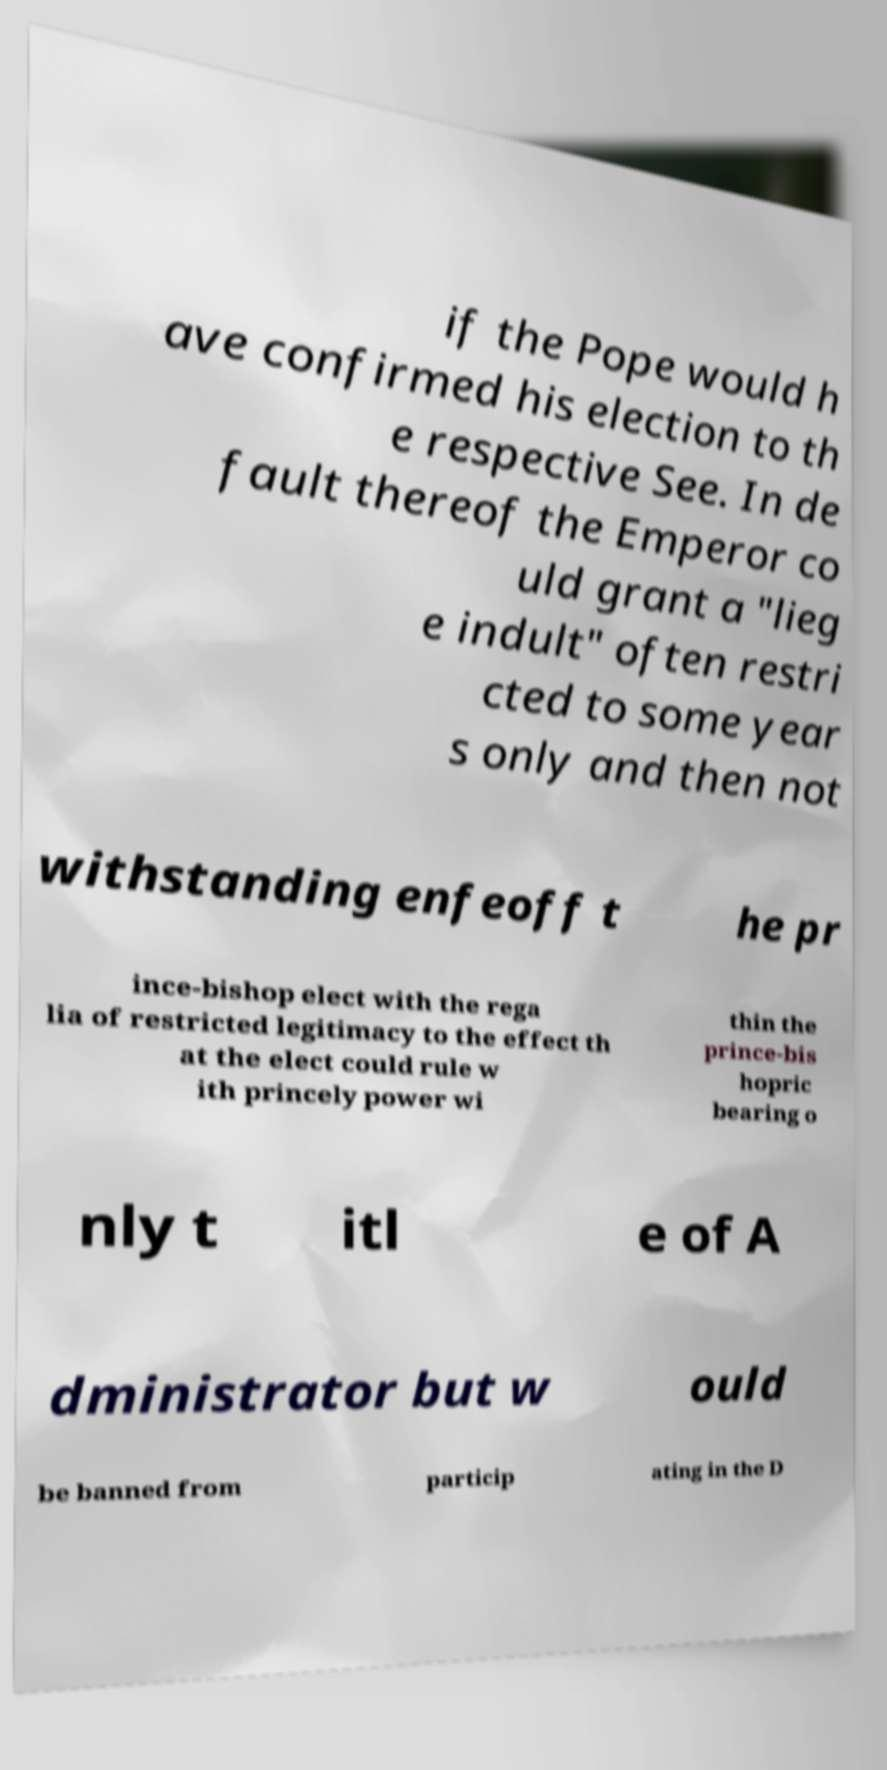Can you read and provide the text displayed in the image?This photo seems to have some interesting text. Can you extract and type it out for me? if the Pope would h ave confirmed his election to th e respective See. In de fault thereof the Emperor co uld grant a "lieg e indult" often restri cted to some year s only and then not withstanding enfeoff t he pr ince-bishop elect with the rega lia of restricted legitimacy to the effect th at the elect could rule w ith princely power wi thin the prince-bis hopric bearing o nly t itl e of A dministrator but w ould be banned from particip ating in the D 